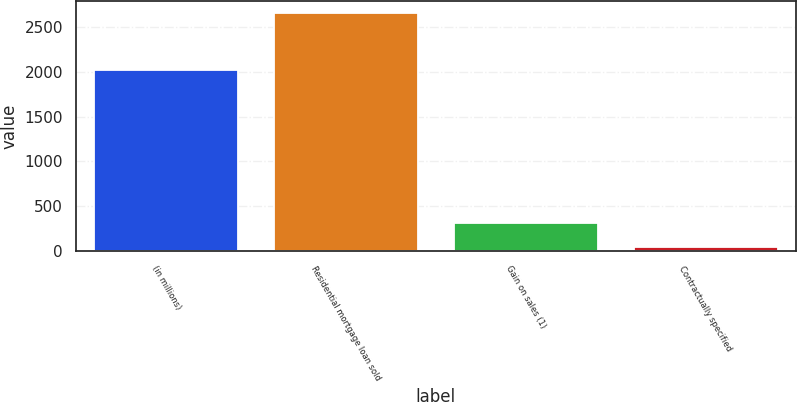Convert chart. <chart><loc_0><loc_0><loc_500><loc_500><bar_chart><fcel>(in millions)<fcel>Residential mortgage loan sold<fcel>Gain on sales (1)<fcel>Contractually specified<nl><fcel>2016<fcel>2652<fcel>311.1<fcel>51<nl></chart> 